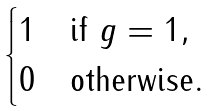Convert formula to latex. <formula><loc_0><loc_0><loc_500><loc_500>\begin{cases} 1 & \text {if $g=1$} , \\ 0 & \text {otherwise} . \end{cases}</formula> 